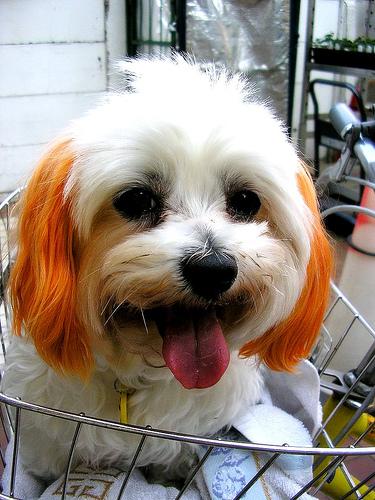What color are the dog's ears?
Keep it brief. Orange. What animal is this?
Write a very short answer. Dog. Is the dog supposed to look like a pumpkin?
Give a very brief answer. No. 